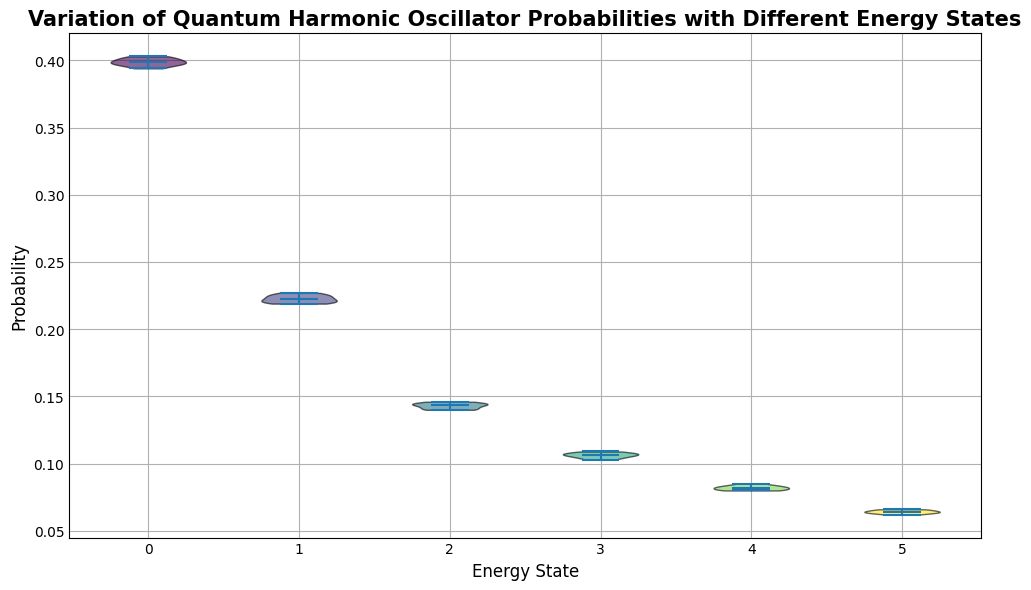What's the median probability for the energy state 3? To find the median, look at the location of the central line within the violin plot for energy state 3. This line represents the median value.
Answer: 0.106 Which energy state shows the highest median probability? Compare the central lines in each of the violin plots. The highest median line indicates the highest median probability.
Answer: Energy State 0 How does the range of probabilities for energy state 1 compare to energy state 5? Observe the width and spread of the violin plots for both energy states. Energy state 1 has a wider spread of probabilities compared to energy state 5, indicating a larger range.
Answer: Energy state 1 has a larger range What is the relationship between the energy state and the overall probability trend? As the energy state increases, the overall trend of the probabilities seems to decrease. This can be observed by noting the height of the violin plots from energy state 0 to energy state 5.
Answer: Probabilities decrease with higher energy states Is there more variation in the probabilities for lower energy states or higher energy states? By looking at the width of the violin plots, we can see wider plots for lower energy states and narrower plots for higher energy states. This indicates more variation in probabilities at lower energy states.
Answer: More variation in lower energy states Compare the median probabilities of energy state 2 and energy state 4. Observe the central lines in the violin plots for energy state 2 and energy state 4. The length of these lines will give us the median values.
Answer: Energy state 2 has a higher median probability than energy state 4 Which energy state shows the smallest range of probabilities? Identify the violin plot with the narrowest spread from top to bottom.
Answer: Energy state 5 Looking at the colors of the violin plots, which energy state appears to be indicated by the lightest shade? The lightest shade among the color gradient used in the plots corresponds to one of the higher energy states.
Answer: Energy state 4 What's the average probability across all energy states? To find the average, sum all the median probabilities of each energy state and divide by the number of energy states. Median probabilities are: 0.4 (state 0), 0.22 (state 1), 0.1445 (state 2), 0.106 (state 3), 0.082 (state 4), and 0.064 (state 5). (0.4 + 0.22 + 0.1445 + 0.106 + 0.082 + 0.064) / 6 = 1.0165 / 6 ≈ 0.1694
Answer: 0.1694 Which energy state has the highest probability outlier and what is its value? Look for the highest individual point that extends beyond the general width of the violin plots.
Answer: Energy state 0, 0.403 